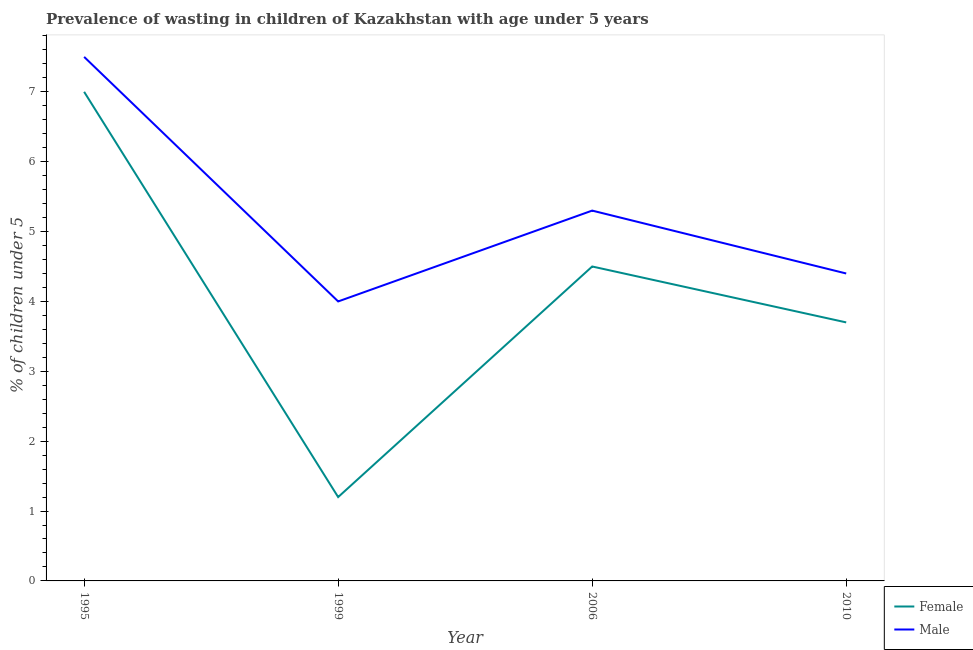Does the line corresponding to percentage of undernourished male children intersect with the line corresponding to percentage of undernourished female children?
Keep it short and to the point. No. Is the number of lines equal to the number of legend labels?
Ensure brevity in your answer.  Yes. What is the percentage of undernourished female children in 1995?
Make the answer very short. 7. Across all years, what is the maximum percentage of undernourished female children?
Offer a very short reply. 7. Across all years, what is the minimum percentage of undernourished female children?
Your answer should be compact. 1.2. In which year was the percentage of undernourished female children minimum?
Make the answer very short. 1999. What is the total percentage of undernourished male children in the graph?
Provide a short and direct response. 21.2. What is the difference between the percentage of undernourished male children in 1995 and that in 2006?
Give a very brief answer. 2.2. What is the difference between the percentage of undernourished male children in 1995 and the percentage of undernourished female children in 1999?
Provide a short and direct response. 6.3. What is the average percentage of undernourished male children per year?
Offer a very short reply. 5.3. In the year 2006, what is the difference between the percentage of undernourished male children and percentage of undernourished female children?
Make the answer very short. 0.8. In how many years, is the percentage of undernourished female children greater than 5.4 %?
Your answer should be very brief. 1. What is the ratio of the percentage of undernourished male children in 1999 to that in 2006?
Keep it short and to the point. 0.75. Is the percentage of undernourished male children in 1995 less than that in 2006?
Make the answer very short. No. What is the difference between the highest and the second highest percentage of undernourished female children?
Your answer should be very brief. 2.5. Is the sum of the percentage of undernourished female children in 1999 and 2006 greater than the maximum percentage of undernourished male children across all years?
Provide a short and direct response. No. Does the percentage of undernourished female children monotonically increase over the years?
Provide a succinct answer. No. Is the percentage of undernourished female children strictly less than the percentage of undernourished male children over the years?
Your response must be concise. Yes. How many years are there in the graph?
Make the answer very short. 4. What is the difference between two consecutive major ticks on the Y-axis?
Provide a succinct answer. 1. Does the graph contain any zero values?
Make the answer very short. No. Does the graph contain grids?
Your answer should be compact. No. Where does the legend appear in the graph?
Give a very brief answer. Bottom right. What is the title of the graph?
Give a very brief answer. Prevalence of wasting in children of Kazakhstan with age under 5 years. Does "Ages 15-24" appear as one of the legend labels in the graph?
Your response must be concise. No. What is the label or title of the X-axis?
Keep it short and to the point. Year. What is the label or title of the Y-axis?
Provide a succinct answer.  % of children under 5. What is the  % of children under 5 of Female in 1995?
Offer a terse response. 7. What is the  % of children under 5 of Female in 1999?
Offer a very short reply. 1.2. What is the  % of children under 5 in Female in 2006?
Provide a succinct answer. 4.5. What is the  % of children under 5 of Male in 2006?
Offer a terse response. 5.3. What is the  % of children under 5 in Female in 2010?
Offer a very short reply. 3.7. What is the  % of children under 5 in Male in 2010?
Ensure brevity in your answer.  4.4. Across all years, what is the maximum  % of children under 5 of Male?
Your answer should be compact. 7.5. Across all years, what is the minimum  % of children under 5 in Female?
Give a very brief answer. 1.2. What is the total  % of children under 5 in Male in the graph?
Keep it short and to the point. 21.2. What is the difference between the  % of children under 5 of Female in 1995 and that in 2010?
Provide a succinct answer. 3.3. What is the difference between the  % of children under 5 in Female in 1995 and the  % of children under 5 in Male in 1999?
Offer a terse response. 3. What is the ratio of the  % of children under 5 of Female in 1995 to that in 1999?
Your answer should be compact. 5.83. What is the ratio of the  % of children under 5 in Male in 1995 to that in 1999?
Keep it short and to the point. 1.88. What is the ratio of the  % of children under 5 in Female in 1995 to that in 2006?
Keep it short and to the point. 1.56. What is the ratio of the  % of children under 5 of Male in 1995 to that in 2006?
Offer a very short reply. 1.42. What is the ratio of the  % of children under 5 in Female in 1995 to that in 2010?
Ensure brevity in your answer.  1.89. What is the ratio of the  % of children under 5 in Male in 1995 to that in 2010?
Your answer should be compact. 1.7. What is the ratio of the  % of children under 5 of Female in 1999 to that in 2006?
Ensure brevity in your answer.  0.27. What is the ratio of the  % of children under 5 of Male in 1999 to that in 2006?
Offer a very short reply. 0.75. What is the ratio of the  % of children under 5 of Female in 1999 to that in 2010?
Ensure brevity in your answer.  0.32. What is the ratio of the  % of children under 5 of Female in 2006 to that in 2010?
Offer a terse response. 1.22. What is the ratio of the  % of children under 5 of Male in 2006 to that in 2010?
Ensure brevity in your answer.  1.2. What is the difference between the highest and the second highest  % of children under 5 of Female?
Your response must be concise. 2.5. What is the difference between the highest and the second highest  % of children under 5 in Male?
Provide a short and direct response. 2.2. What is the difference between the highest and the lowest  % of children under 5 in Female?
Make the answer very short. 5.8. 